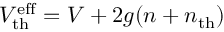<formula> <loc_0><loc_0><loc_500><loc_500>V _ { t h } ^ { e f f } = V + 2 g ( n + n _ { t h } )</formula> 